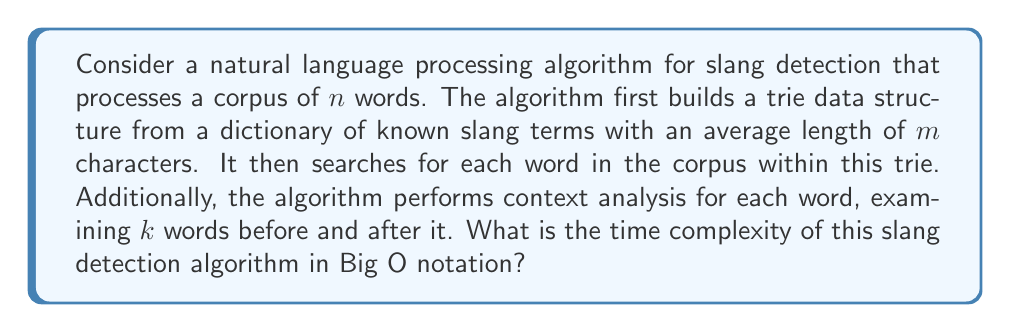Can you solve this math problem? To analyze the time complexity of this algorithm, let's break it down into steps:

1. Building the trie:
   - For each slang term, we insert it into the trie.
   - Insertion of a word with $m$ characters takes $O(m)$ time.
   - If we have $s$ slang terms in our dictionary, the total time to build the trie is $O(s \cdot m)$.

2. Searching for words in the trie:
   - For each of the $n$ words in the corpus, we search the trie.
   - Searching for a word of length $m$ in the trie takes $O(m)$ time.
   - Total time for searching: $O(n \cdot m)$.

3. Context analysis:
   - For each word, we examine $k$ words before and after it.
   - This operation is performed $n$ times (once for each word in the corpus).
   - The time for context analysis is $O(n \cdot k)$.

Combining these steps, the total time complexity is:

$$O(s \cdot m + n \cdot m + n \cdot k)$$

We can simplify this expression:
   - $s$ (number of slang terms) is typically much smaller than $n$ (corpus size), so $s \cdot m$ becomes negligible compared to $n \cdot m$.
   - $m$ (average word length) is generally considered constant in natural language processing.
   - $k$ (context window size) is also typically a small constant.

Therefore, we can simplify the time complexity to:

$$O(n)$$

This linear time complexity indicates that the algorithm's runtime grows linearly with the size of the input corpus.
Answer: $O(n)$, where $n$ is the number of words in the corpus. 